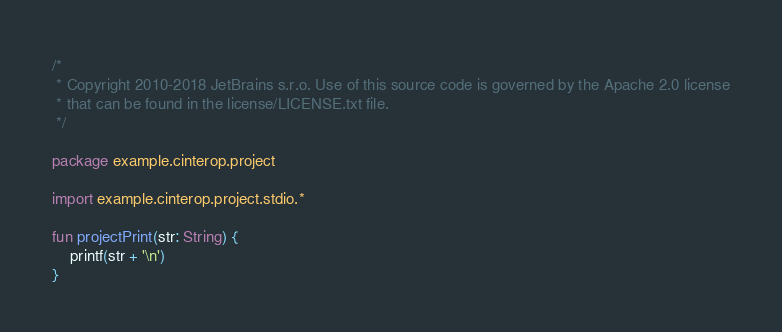Convert code to text. <code><loc_0><loc_0><loc_500><loc_500><_Kotlin_>/*
 * Copyright 2010-2018 JetBrains s.r.o. Use of this source code is governed by the Apache 2.0 license
 * that can be found in the license/LICENSE.txt file.
 */

package example.cinterop.project

import example.cinterop.project.stdio.*

fun projectPrint(str: String) {
    printf(str + '\n')
}
</code> 